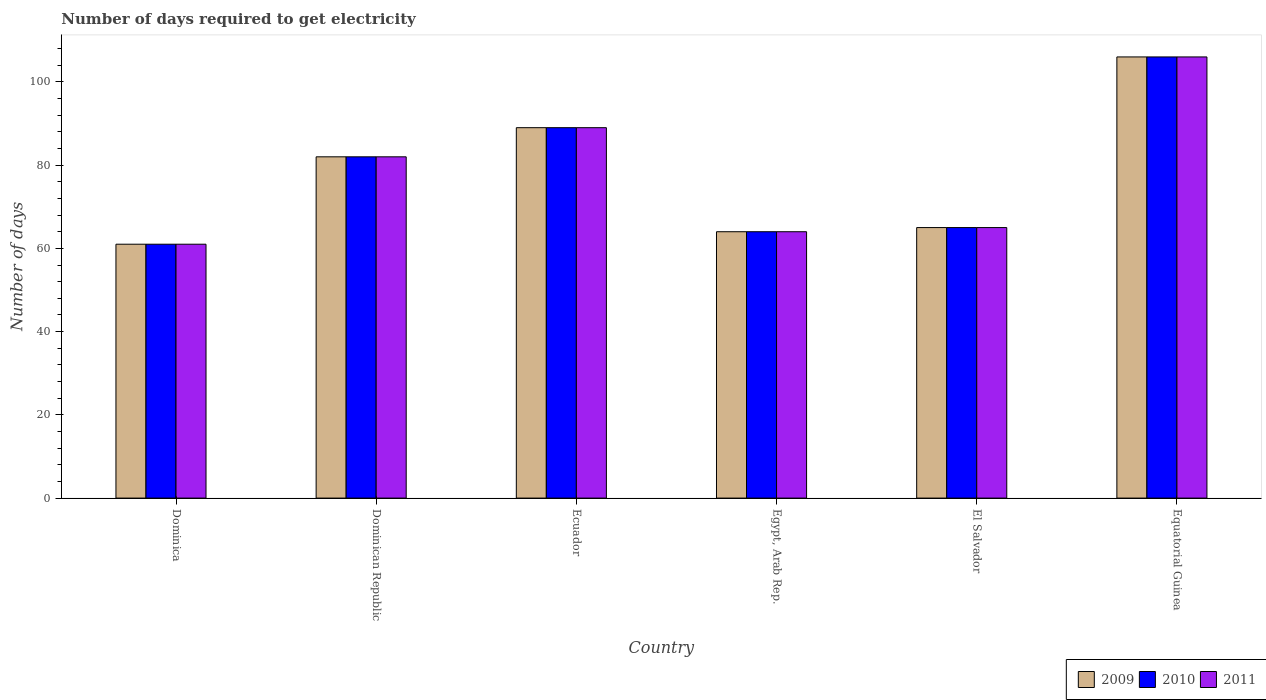How many groups of bars are there?
Provide a short and direct response. 6. Are the number of bars per tick equal to the number of legend labels?
Your response must be concise. Yes. What is the label of the 4th group of bars from the left?
Offer a very short reply. Egypt, Arab Rep. In how many cases, is the number of bars for a given country not equal to the number of legend labels?
Offer a terse response. 0. What is the number of days required to get electricity in in 2009 in Equatorial Guinea?
Give a very brief answer. 106. Across all countries, what is the maximum number of days required to get electricity in in 2011?
Your answer should be compact. 106. Across all countries, what is the minimum number of days required to get electricity in in 2011?
Ensure brevity in your answer.  61. In which country was the number of days required to get electricity in in 2010 maximum?
Your answer should be compact. Equatorial Guinea. In which country was the number of days required to get electricity in in 2011 minimum?
Make the answer very short. Dominica. What is the total number of days required to get electricity in in 2011 in the graph?
Give a very brief answer. 467. What is the difference between the number of days required to get electricity in in 2011 in El Salvador and the number of days required to get electricity in in 2010 in Dominica?
Give a very brief answer. 4. What is the average number of days required to get electricity in in 2011 per country?
Ensure brevity in your answer.  77.83. What is the difference between the number of days required to get electricity in of/in 2011 and number of days required to get electricity in of/in 2010 in Dominican Republic?
Your response must be concise. 0. What is the ratio of the number of days required to get electricity in in 2009 in Egypt, Arab Rep. to that in El Salvador?
Your answer should be compact. 0.98. Is the number of days required to get electricity in in 2011 in Ecuador less than that in El Salvador?
Offer a very short reply. No. What is the difference between the highest and the lowest number of days required to get electricity in in 2011?
Keep it short and to the point. 45. In how many countries, is the number of days required to get electricity in in 2011 greater than the average number of days required to get electricity in in 2011 taken over all countries?
Keep it short and to the point. 3. What does the 2nd bar from the left in El Salvador represents?
Offer a very short reply. 2010. What does the 2nd bar from the right in Ecuador represents?
Keep it short and to the point. 2010. How many bars are there?
Your response must be concise. 18. Are all the bars in the graph horizontal?
Keep it short and to the point. No. What is the difference between two consecutive major ticks on the Y-axis?
Keep it short and to the point. 20. Are the values on the major ticks of Y-axis written in scientific E-notation?
Keep it short and to the point. No. Does the graph contain any zero values?
Offer a terse response. No. Where does the legend appear in the graph?
Your answer should be very brief. Bottom right. What is the title of the graph?
Your answer should be compact. Number of days required to get electricity. Does "1987" appear as one of the legend labels in the graph?
Provide a succinct answer. No. What is the label or title of the X-axis?
Give a very brief answer. Country. What is the label or title of the Y-axis?
Give a very brief answer. Number of days. What is the Number of days of 2009 in Dominica?
Give a very brief answer. 61. What is the Number of days of 2010 in Dominica?
Make the answer very short. 61. What is the Number of days of 2009 in Ecuador?
Keep it short and to the point. 89. What is the Number of days in 2010 in Ecuador?
Your answer should be very brief. 89. What is the Number of days in 2011 in Ecuador?
Give a very brief answer. 89. What is the Number of days of 2009 in Egypt, Arab Rep.?
Offer a very short reply. 64. What is the Number of days in 2009 in El Salvador?
Offer a very short reply. 65. What is the Number of days of 2010 in El Salvador?
Keep it short and to the point. 65. What is the Number of days in 2009 in Equatorial Guinea?
Give a very brief answer. 106. What is the Number of days in 2010 in Equatorial Guinea?
Ensure brevity in your answer.  106. What is the Number of days of 2011 in Equatorial Guinea?
Your answer should be compact. 106. Across all countries, what is the maximum Number of days of 2009?
Your answer should be very brief. 106. Across all countries, what is the maximum Number of days in 2010?
Make the answer very short. 106. Across all countries, what is the maximum Number of days of 2011?
Provide a short and direct response. 106. Across all countries, what is the minimum Number of days of 2009?
Offer a terse response. 61. Across all countries, what is the minimum Number of days in 2011?
Your answer should be compact. 61. What is the total Number of days in 2009 in the graph?
Offer a terse response. 467. What is the total Number of days of 2010 in the graph?
Your answer should be compact. 467. What is the total Number of days of 2011 in the graph?
Ensure brevity in your answer.  467. What is the difference between the Number of days in 2011 in Dominica and that in Dominican Republic?
Provide a short and direct response. -21. What is the difference between the Number of days of 2009 in Dominica and that in Ecuador?
Your answer should be compact. -28. What is the difference between the Number of days in 2010 in Dominica and that in Egypt, Arab Rep.?
Your answer should be very brief. -3. What is the difference between the Number of days of 2009 in Dominica and that in El Salvador?
Offer a terse response. -4. What is the difference between the Number of days in 2010 in Dominica and that in El Salvador?
Offer a very short reply. -4. What is the difference between the Number of days in 2011 in Dominica and that in El Salvador?
Give a very brief answer. -4. What is the difference between the Number of days in 2009 in Dominica and that in Equatorial Guinea?
Provide a succinct answer. -45. What is the difference between the Number of days of 2010 in Dominica and that in Equatorial Guinea?
Your answer should be compact. -45. What is the difference between the Number of days of 2011 in Dominica and that in Equatorial Guinea?
Your response must be concise. -45. What is the difference between the Number of days in 2010 in Dominican Republic and that in Ecuador?
Provide a succinct answer. -7. What is the difference between the Number of days of 2010 in Dominican Republic and that in Egypt, Arab Rep.?
Your answer should be compact. 18. What is the difference between the Number of days in 2011 in Dominican Republic and that in Egypt, Arab Rep.?
Provide a succinct answer. 18. What is the difference between the Number of days of 2010 in Dominican Republic and that in El Salvador?
Give a very brief answer. 17. What is the difference between the Number of days in 2009 in Dominican Republic and that in Equatorial Guinea?
Your response must be concise. -24. What is the difference between the Number of days in 2010 in Dominican Republic and that in Equatorial Guinea?
Your response must be concise. -24. What is the difference between the Number of days of 2011 in Dominican Republic and that in Equatorial Guinea?
Your response must be concise. -24. What is the difference between the Number of days in 2011 in Ecuador and that in El Salvador?
Your answer should be very brief. 24. What is the difference between the Number of days in 2010 in Ecuador and that in Equatorial Guinea?
Your answer should be compact. -17. What is the difference between the Number of days of 2011 in Ecuador and that in Equatorial Guinea?
Your response must be concise. -17. What is the difference between the Number of days in 2011 in Egypt, Arab Rep. and that in El Salvador?
Keep it short and to the point. -1. What is the difference between the Number of days in 2009 in Egypt, Arab Rep. and that in Equatorial Guinea?
Your answer should be compact. -42. What is the difference between the Number of days in 2010 in Egypt, Arab Rep. and that in Equatorial Guinea?
Make the answer very short. -42. What is the difference between the Number of days in 2011 in Egypt, Arab Rep. and that in Equatorial Guinea?
Provide a succinct answer. -42. What is the difference between the Number of days in 2009 in El Salvador and that in Equatorial Guinea?
Your answer should be very brief. -41. What is the difference between the Number of days of 2010 in El Salvador and that in Equatorial Guinea?
Your response must be concise. -41. What is the difference between the Number of days of 2011 in El Salvador and that in Equatorial Guinea?
Provide a succinct answer. -41. What is the difference between the Number of days of 2009 in Dominica and the Number of days of 2011 in Dominican Republic?
Offer a very short reply. -21. What is the difference between the Number of days of 2009 in Dominica and the Number of days of 2010 in Egypt, Arab Rep.?
Ensure brevity in your answer.  -3. What is the difference between the Number of days in 2009 in Dominica and the Number of days in 2011 in Egypt, Arab Rep.?
Give a very brief answer. -3. What is the difference between the Number of days in 2009 in Dominica and the Number of days in 2010 in El Salvador?
Your answer should be compact. -4. What is the difference between the Number of days of 2009 in Dominica and the Number of days of 2010 in Equatorial Guinea?
Your answer should be very brief. -45. What is the difference between the Number of days in 2009 in Dominica and the Number of days in 2011 in Equatorial Guinea?
Offer a terse response. -45. What is the difference between the Number of days in 2010 in Dominica and the Number of days in 2011 in Equatorial Guinea?
Your response must be concise. -45. What is the difference between the Number of days in 2009 in Dominican Republic and the Number of days in 2011 in Ecuador?
Make the answer very short. -7. What is the difference between the Number of days of 2010 in Dominican Republic and the Number of days of 2011 in Ecuador?
Keep it short and to the point. -7. What is the difference between the Number of days of 2010 in Dominican Republic and the Number of days of 2011 in Egypt, Arab Rep.?
Ensure brevity in your answer.  18. What is the difference between the Number of days of 2010 in Dominican Republic and the Number of days of 2011 in El Salvador?
Your answer should be compact. 17. What is the difference between the Number of days of 2009 in Dominican Republic and the Number of days of 2011 in Equatorial Guinea?
Give a very brief answer. -24. What is the difference between the Number of days of 2010 in Dominican Republic and the Number of days of 2011 in Equatorial Guinea?
Give a very brief answer. -24. What is the difference between the Number of days in 2009 in Ecuador and the Number of days in 2011 in Egypt, Arab Rep.?
Provide a succinct answer. 25. What is the difference between the Number of days of 2009 in Ecuador and the Number of days of 2010 in El Salvador?
Keep it short and to the point. 24. What is the difference between the Number of days in 2009 in Ecuador and the Number of days in 2011 in El Salvador?
Your answer should be very brief. 24. What is the difference between the Number of days of 2009 in Ecuador and the Number of days of 2010 in Equatorial Guinea?
Give a very brief answer. -17. What is the difference between the Number of days of 2009 in Ecuador and the Number of days of 2011 in Equatorial Guinea?
Give a very brief answer. -17. What is the difference between the Number of days of 2009 in Egypt, Arab Rep. and the Number of days of 2010 in El Salvador?
Make the answer very short. -1. What is the difference between the Number of days of 2010 in Egypt, Arab Rep. and the Number of days of 2011 in El Salvador?
Your answer should be very brief. -1. What is the difference between the Number of days in 2009 in Egypt, Arab Rep. and the Number of days in 2010 in Equatorial Guinea?
Provide a short and direct response. -42. What is the difference between the Number of days of 2009 in Egypt, Arab Rep. and the Number of days of 2011 in Equatorial Guinea?
Give a very brief answer. -42. What is the difference between the Number of days in 2010 in Egypt, Arab Rep. and the Number of days in 2011 in Equatorial Guinea?
Offer a terse response. -42. What is the difference between the Number of days in 2009 in El Salvador and the Number of days in 2010 in Equatorial Guinea?
Provide a short and direct response. -41. What is the difference between the Number of days of 2009 in El Salvador and the Number of days of 2011 in Equatorial Guinea?
Provide a succinct answer. -41. What is the difference between the Number of days of 2010 in El Salvador and the Number of days of 2011 in Equatorial Guinea?
Give a very brief answer. -41. What is the average Number of days of 2009 per country?
Make the answer very short. 77.83. What is the average Number of days in 2010 per country?
Provide a succinct answer. 77.83. What is the average Number of days in 2011 per country?
Offer a terse response. 77.83. What is the difference between the Number of days of 2009 and Number of days of 2010 in Dominica?
Offer a terse response. 0. What is the difference between the Number of days in 2009 and Number of days in 2011 in Dominican Republic?
Your answer should be compact. 0. What is the difference between the Number of days of 2010 and Number of days of 2011 in Dominican Republic?
Offer a very short reply. 0. What is the difference between the Number of days in 2009 and Number of days in 2010 in Ecuador?
Make the answer very short. 0. What is the difference between the Number of days of 2009 and Number of days of 2010 in Egypt, Arab Rep.?
Offer a very short reply. 0. What is the difference between the Number of days of 2009 and Number of days of 2010 in El Salvador?
Your response must be concise. 0. What is the difference between the Number of days of 2009 and Number of days of 2010 in Equatorial Guinea?
Ensure brevity in your answer.  0. What is the difference between the Number of days in 2009 and Number of days in 2011 in Equatorial Guinea?
Your answer should be compact. 0. What is the ratio of the Number of days in 2009 in Dominica to that in Dominican Republic?
Your response must be concise. 0.74. What is the ratio of the Number of days of 2010 in Dominica to that in Dominican Republic?
Provide a succinct answer. 0.74. What is the ratio of the Number of days of 2011 in Dominica to that in Dominican Republic?
Provide a succinct answer. 0.74. What is the ratio of the Number of days of 2009 in Dominica to that in Ecuador?
Make the answer very short. 0.69. What is the ratio of the Number of days in 2010 in Dominica to that in Ecuador?
Offer a terse response. 0.69. What is the ratio of the Number of days of 2011 in Dominica to that in Ecuador?
Your answer should be very brief. 0.69. What is the ratio of the Number of days in 2009 in Dominica to that in Egypt, Arab Rep.?
Offer a very short reply. 0.95. What is the ratio of the Number of days of 2010 in Dominica to that in Egypt, Arab Rep.?
Your response must be concise. 0.95. What is the ratio of the Number of days of 2011 in Dominica to that in Egypt, Arab Rep.?
Make the answer very short. 0.95. What is the ratio of the Number of days of 2009 in Dominica to that in El Salvador?
Give a very brief answer. 0.94. What is the ratio of the Number of days in 2010 in Dominica to that in El Salvador?
Make the answer very short. 0.94. What is the ratio of the Number of days in 2011 in Dominica to that in El Salvador?
Ensure brevity in your answer.  0.94. What is the ratio of the Number of days of 2009 in Dominica to that in Equatorial Guinea?
Offer a very short reply. 0.58. What is the ratio of the Number of days of 2010 in Dominica to that in Equatorial Guinea?
Your answer should be very brief. 0.58. What is the ratio of the Number of days in 2011 in Dominica to that in Equatorial Guinea?
Make the answer very short. 0.58. What is the ratio of the Number of days in 2009 in Dominican Republic to that in Ecuador?
Ensure brevity in your answer.  0.92. What is the ratio of the Number of days of 2010 in Dominican Republic to that in Ecuador?
Your answer should be very brief. 0.92. What is the ratio of the Number of days in 2011 in Dominican Republic to that in Ecuador?
Provide a short and direct response. 0.92. What is the ratio of the Number of days of 2009 in Dominican Republic to that in Egypt, Arab Rep.?
Give a very brief answer. 1.28. What is the ratio of the Number of days of 2010 in Dominican Republic to that in Egypt, Arab Rep.?
Make the answer very short. 1.28. What is the ratio of the Number of days of 2011 in Dominican Republic to that in Egypt, Arab Rep.?
Give a very brief answer. 1.28. What is the ratio of the Number of days of 2009 in Dominican Republic to that in El Salvador?
Your answer should be compact. 1.26. What is the ratio of the Number of days in 2010 in Dominican Republic to that in El Salvador?
Your answer should be compact. 1.26. What is the ratio of the Number of days of 2011 in Dominican Republic to that in El Salvador?
Your answer should be very brief. 1.26. What is the ratio of the Number of days of 2009 in Dominican Republic to that in Equatorial Guinea?
Keep it short and to the point. 0.77. What is the ratio of the Number of days of 2010 in Dominican Republic to that in Equatorial Guinea?
Provide a short and direct response. 0.77. What is the ratio of the Number of days in 2011 in Dominican Republic to that in Equatorial Guinea?
Ensure brevity in your answer.  0.77. What is the ratio of the Number of days in 2009 in Ecuador to that in Egypt, Arab Rep.?
Provide a succinct answer. 1.39. What is the ratio of the Number of days in 2010 in Ecuador to that in Egypt, Arab Rep.?
Your response must be concise. 1.39. What is the ratio of the Number of days of 2011 in Ecuador to that in Egypt, Arab Rep.?
Provide a succinct answer. 1.39. What is the ratio of the Number of days in 2009 in Ecuador to that in El Salvador?
Provide a short and direct response. 1.37. What is the ratio of the Number of days in 2010 in Ecuador to that in El Salvador?
Your answer should be compact. 1.37. What is the ratio of the Number of days in 2011 in Ecuador to that in El Salvador?
Provide a succinct answer. 1.37. What is the ratio of the Number of days in 2009 in Ecuador to that in Equatorial Guinea?
Keep it short and to the point. 0.84. What is the ratio of the Number of days in 2010 in Ecuador to that in Equatorial Guinea?
Provide a succinct answer. 0.84. What is the ratio of the Number of days of 2011 in Ecuador to that in Equatorial Guinea?
Offer a terse response. 0.84. What is the ratio of the Number of days in 2009 in Egypt, Arab Rep. to that in El Salvador?
Provide a short and direct response. 0.98. What is the ratio of the Number of days in 2010 in Egypt, Arab Rep. to that in El Salvador?
Ensure brevity in your answer.  0.98. What is the ratio of the Number of days of 2011 in Egypt, Arab Rep. to that in El Salvador?
Make the answer very short. 0.98. What is the ratio of the Number of days of 2009 in Egypt, Arab Rep. to that in Equatorial Guinea?
Make the answer very short. 0.6. What is the ratio of the Number of days of 2010 in Egypt, Arab Rep. to that in Equatorial Guinea?
Provide a short and direct response. 0.6. What is the ratio of the Number of days of 2011 in Egypt, Arab Rep. to that in Equatorial Guinea?
Give a very brief answer. 0.6. What is the ratio of the Number of days of 2009 in El Salvador to that in Equatorial Guinea?
Make the answer very short. 0.61. What is the ratio of the Number of days of 2010 in El Salvador to that in Equatorial Guinea?
Offer a very short reply. 0.61. What is the ratio of the Number of days in 2011 in El Salvador to that in Equatorial Guinea?
Your response must be concise. 0.61. What is the difference between the highest and the second highest Number of days of 2009?
Your response must be concise. 17. What is the difference between the highest and the second highest Number of days of 2010?
Offer a very short reply. 17. What is the difference between the highest and the lowest Number of days of 2010?
Your response must be concise. 45. 